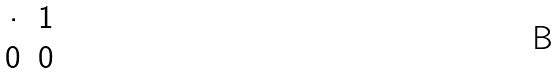Convert formula to latex. <formula><loc_0><loc_0><loc_500><loc_500>\begin{matrix} \cdot & 1 \\ 0 & 0 \end{matrix}</formula> 